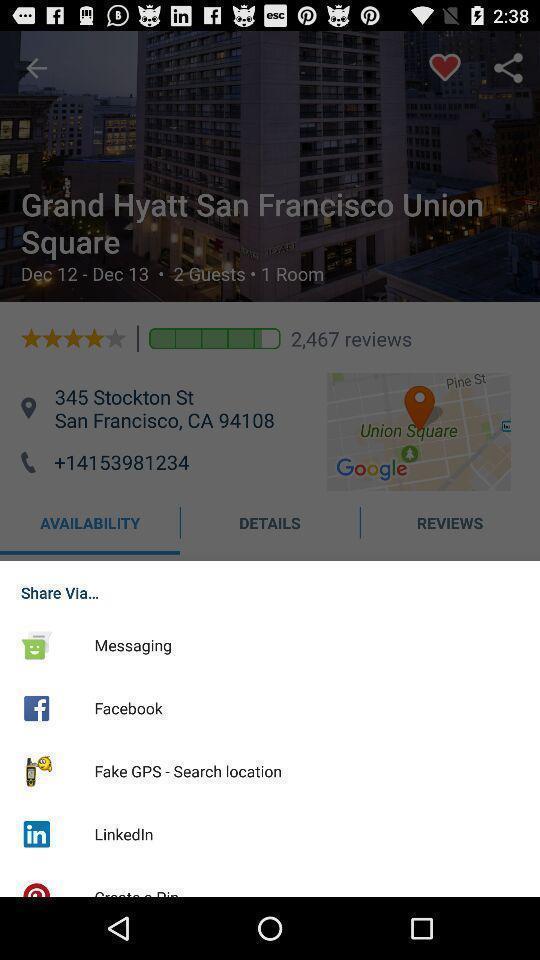Tell me about the visual elements in this screen capture. Pop-up showing different sharing options. 